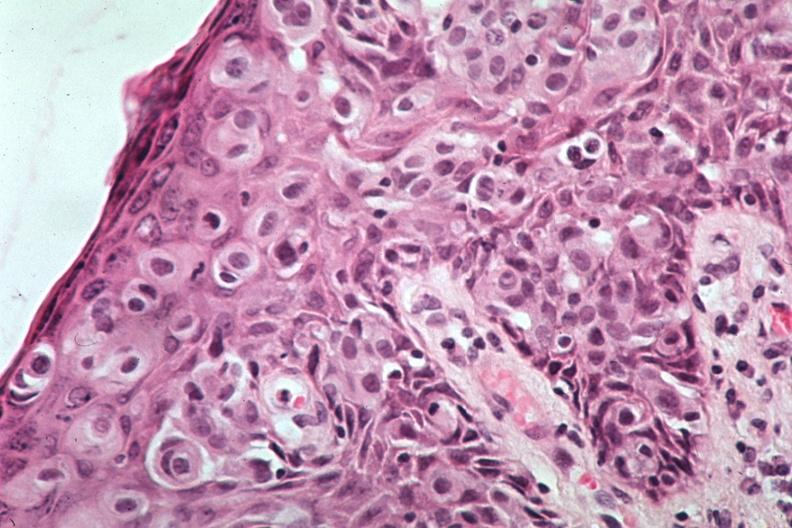where is this area in the body?
Answer the question using a single word or phrase. Breast 